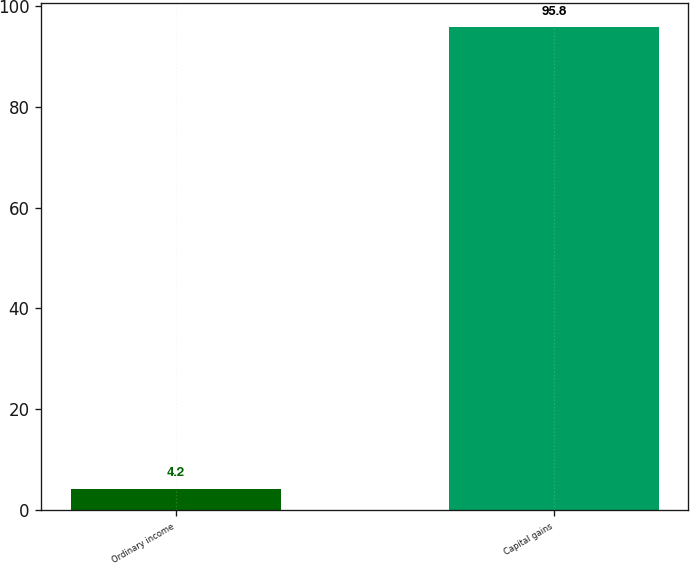Convert chart to OTSL. <chart><loc_0><loc_0><loc_500><loc_500><bar_chart><fcel>Ordinary income<fcel>Capital gains<nl><fcel>4.2<fcel>95.8<nl></chart> 